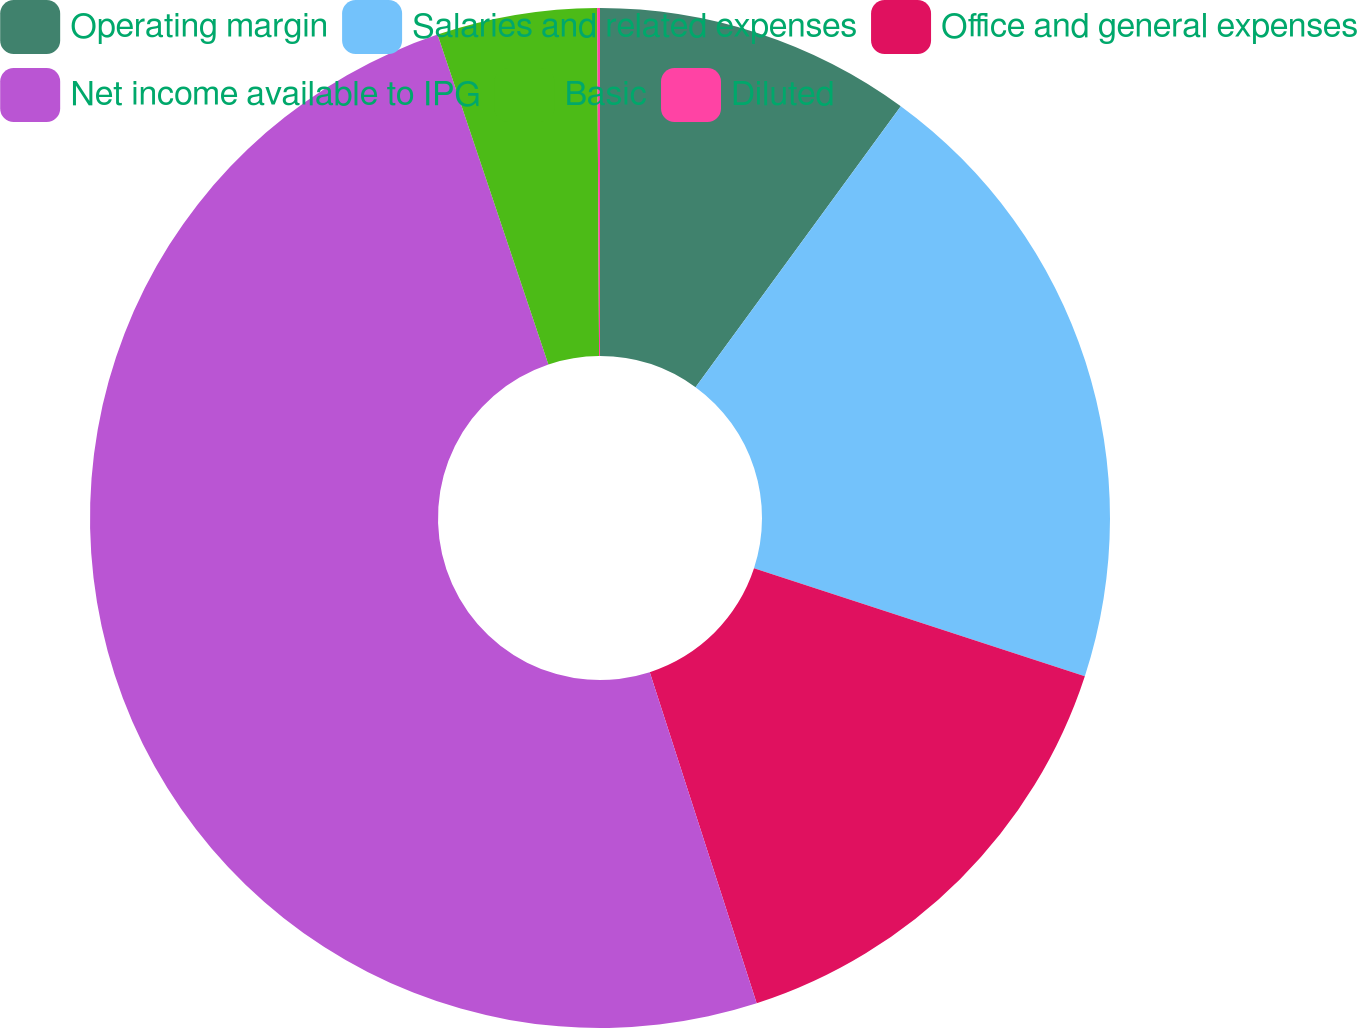Convert chart to OTSL. <chart><loc_0><loc_0><loc_500><loc_500><pie_chart><fcel>Operating margin<fcel>Salaries and related expenses<fcel>Office and general expenses<fcel>Net income available to IPG<fcel>Basic<fcel>Diluted<nl><fcel>10.04%<fcel>19.98%<fcel>15.01%<fcel>49.81%<fcel>5.07%<fcel>0.09%<nl></chart> 